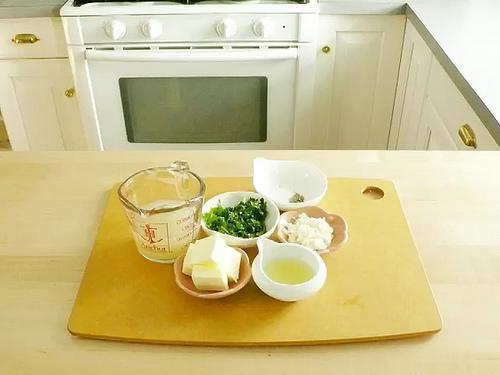How many measuring cups are on the cutting board?
Give a very brief answer. 1. 